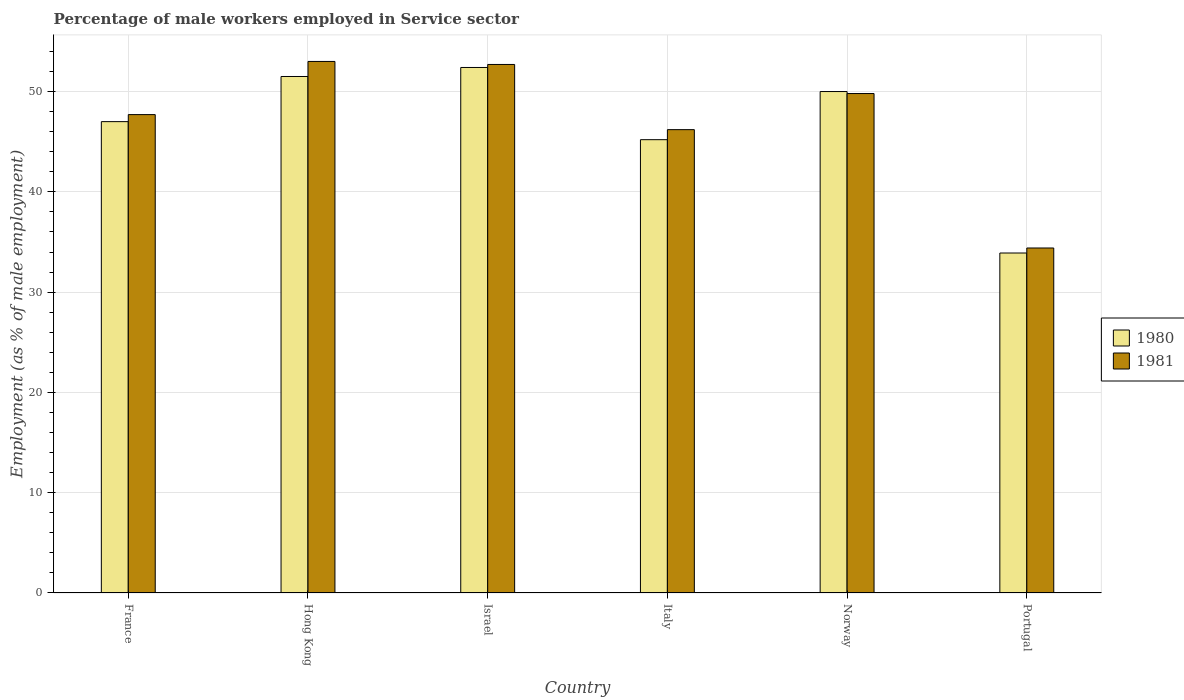Are the number of bars per tick equal to the number of legend labels?
Make the answer very short. Yes. Are the number of bars on each tick of the X-axis equal?
Keep it short and to the point. Yes. What is the percentage of male workers employed in Service sector in 1980 in France?
Keep it short and to the point. 47. Across all countries, what is the maximum percentage of male workers employed in Service sector in 1980?
Make the answer very short. 52.4. Across all countries, what is the minimum percentage of male workers employed in Service sector in 1980?
Offer a very short reply. 33.9. In which country was the percentage of male workers employed in Service sector in 1981 maximum?
Your response must be concise. Hong Kong. What is the total percentage of male workers employed in Service sector in 1981 in the graph?
Your response must be concise. 283.8. What is the difference between the percentage of male workers employed in Service sector in 1981 in France and the percentage of male workers employed in Service sector in 1980 in Portugal?
Your answer should be very brief. 13.8. What is the average percentage of male workers employed in Service sector in 1980 per country?
Keep it short and to the point. 46.67. What is the ratio of the percentage of male workers employed in Service sector in 1981 in Israel to that in Norway?
Your answer should be compact. 1.06. What is the difference between the highest and the second highest percentage of male workers employed in Service sector in 1981?
Offer a very short reply. -2.9. What is the difference between the highest and the lowest percentage of male workers employed in Service sector in 1980?
Offer a very short reply. 18.5. In how many countries, is the percentage of male workers employed in Service sector in 1980 greater than the average percentage of male workers employed in Service sector in 1980 taken over all countries?
Your response must be concise. 4. What does the 1st bar from the left in Norway represents?
Your answer should be compact. 1980. What does the 1st bar from the right in France represents?
Offer a very short reply. 1981. Are all the bars in the graph horizontal?
Give a very brief answer. No. How many countries are there in the graph?
Your answer should be compact. 6. Does the graph contain any zero values?
Provide a short and direct response. No. Does the graph contain grids?
Ensure brevity in your answer.  Yes. How many legend labels are there?
Keep it short and to the point. 2. How are the legend labels stacked?
Ensure brevity in your answer.  Vertical. What is the title of the graph?
Your response must be concise. Percentage of male workers employed in Service sector. Does "2011" appear as one of the legend labels in the graph?
Offer a very short reply. No. What is the label or title of the Y-axis?
Offer a very short reply. Employment (as % of male employment). What is the Employment (as % of male employment) in 1980 in France?
Give a very brief answer. 47. What is the Employment (as % of male employment) of 1981 in France?
Offer a very short reply. 47.7. What is the Employment (as % of male employment) in 1980 in Hong Kong?
Your answer should be compact. 51.5. What is the Employment (as % of male employment) in 1980 in Israel?
Your answer should be very brief. 52.4. What is the Employment (as % of male employment) of 1981 in Israel?
Offer a terse response. 52.7. What is the Employment (as % of male employment) of 1980 in Italy?
Offer a very short reply. 45.2. What is the Employment (as % of male employment) in 1981 in Italy?
Provide a short and direct response. 46.2. What is the Employment (as % of male employment) of 1980 in Norway?
Make the answer very short. 50. What is the Employment (as % of male employment) of 1981 in Norway?
Your answer should be very brief. 49.8. What is the Employment (as % of male employment) of 1980 in Portugal?
Your answer should be very brief. 33.9. What is the Employment (as % of male employment) of 1981 in Portugal?
Your answer should be compact. 34.4. Across all countries, what is the maximum Employment (as % of male employment) in 1980?
Offer a very short reply. 52.4. Across all countries, what is the minimum Employment (as % of male employment) in 1980?
Your answer should be very brief. 33.9. Across all countries, what is the minimum Employment (as % of male employment) of 1981?
Give a very brief answer. 34.4. What is the total Employment (as % of male employment) in 1980 in the graph?
Provide a short and direct response. 280. What is the total Employment (as % of male employment) in 1981 in the graph?
Keep it short and to the point. 283.8. What is the difference between the Employment (as % of male employment) of 1980 in France and that in Hong Kong?
Ensure brevity in your answer.  -4.5. What is the difference between the Employment (as % of male employment) of 1980 in France and that in Italy?
Ensure brevity in your answer.  1.8. What is the difference between the Employment (as % of male employment) in 1980 in France and that in Portugal?
Provide a short and direct response. 13.1. What is the difference between the Employment (as % of male employment) in 1981 in France and that in Portugal?
Your answer should be compact. 13.3. What is the difference between the Employment (as % of male employment) of 1980 in Hong Kong and that in Israel?
Your answer should be compact. -0.9. What is the difference between the Employment (as % of male employment) in 1981 in Hong Kong and that in Israel?
Provide a short and direct response. 0.3. What is the difference between the Employment (as % of male employment) in 1981 in Hong Kong and that in Italy?
Your answer should be very brief. 6.8. What is the difference between the Employment (as % of male employment) of 1980 in Hong Kong and that in Norway?
Your answer should be very brief. 1.5. What is the difference between the Employment (as % of male employment) of 1980 in Hong Kong and that in Portugal?
Provide a succinct answer. 17.6. What is the difference between the Employment (as % of male employment) in 1980 in Israel and that in Italy?
Keep it short and to the point. 7.2. What is the difference between the Employment (as % of male employment) of 1981 in Israel and that in Norway?
Your answer should be compact. 2.9. What is the difference between the Employment (as % of male employment) in 1980 in Israel and that in Portugal?
Offer a very short reply. 18.5. What is the difference between the Employment (as % of male employment) in 1981 in Italy and that in Norway?
Give a very brief answer. -3.6. What is the difference between the Employment (as % of male employment) in 1980 in Italy and that in Portugal?
Your answer should be very brief. 11.3. What is the difference between the Employment (as % of male employment) of 1981 in Italy and that in Portugal?
Ensure brevity in your answer.  11.8. What is the difference between the Employment (as % of male employment) of 1981 in Norway and that in Portugal?
Give a very brief answer. 15.4. What is the difference between the Employment (as % of male employment) in 1980 in France and the Employment (as % of male employment) in 1981 in Hong Kong?
Offer a terse response. -6. What is the difference between the Employment (as % of male employment) of 1980 in France and the Employment (as % of male employment) of 1981 in Israel?
Keep it short and to the point. -5.7. What is the difference between the Employment (as % of male employment) in 1980 in France and the Employment (as % of male employment) in 1981 in Italy?
Ensure brevity in your answer.  0.8. What is the difference between the Employment (as % of male employment) of 1980 in France and the Employment (as % of male employment) of 1981 in Portugal?
Give a very brief answer. 12.6. What is the difference between the Employment (as % of male employment) in 1980 in Hong Kong and the Employment (as % of male employment) in 1981 in Italy?
Ensure brevity in your answer.  5.3. What is the difference between the Employment (as % of male employment) in 1980 in Hong Kong and the Employment (as % of male employment) in 1981 in Portugal?
Provide a short and direct response. 17.1. What is the difference between the Employment (as % of male employment) in 1980 in Israel and the Employment (as % of male employment) in 1981 in Italy?
Offer a very short reply. 6.2. What is the difference between the Employment (as % of male employment) in 1980 in Israel and the Employment (as % of male employment) in 1981 in Norway?
Make the answer very short. 2.6. What is the average Employment (as % of male employment) in 1980 per country?
Make the answer very short. 46.67. What is the average Employment (as % of male employment) in 1981 per country?
Provide a succinct answer. 47.3. What is the difference between the Employment (as % of male employment) in 1980 and Employment (as % of male employment) in 1981 in France?
Your answer should be compact. -0.7. What is the difference between the Employment (as % of male employment) in 1980 and Employment (as % of male employment) in 1981 in Norway?
Your answer should be very brief. 0.2. What is the ratio of the Employment (as % of male employment) of 1980 in France to that in Hong Kong?
Keep it short and to the point. 0.91. What is the ratio of the Employment (as % of male employment) of 1980 in France to that in Israel?
Provide a short and direct response. 0.9. What is the ratio of the Employment (as % of male employment) of 1981 in France to that in Israel?
Your response must be concise. 0.91. What is the ratio of the Employment (as % of male employment) of 1980 in France to that in Italy?
Provide a succinct answer. 1.04. What is the ratio of the Employment (as % of male employment) in 1981 in France to that in Italy?
Your response must be concise. 1.03. What is the ratio of the Employment (as % of male employment) of 1981 in France to that in Norway?
Make the answer very short. 0.96. What is the ratio of the Employment (as % of male employment) of 1980 in France to that in Portugal?
Give a very brief answer. 1.39. What is the ratio of the Employment (as % of male employment) in 1981 in France to that in Portugal?
Offer a terse response. 1.39. What is the ratio of the Employment (as % of male employment) in 1980 in Hong Kong to that in Israel?
Ensure brevity in your answer.  0.98. What is the ratio of the Employment (as % of male employment) of 1980 in Hong Kong to that in Italy?
Offer a terse response. 1.14. What is the ratio of the Employment (as % of male employment) in 1981 in Hong Kong to that in Italy?
Keep it short and to the point. 1.15. What is the ratio of the Employment (as % of male employment) of 1981 in Hong Kong to that in Norway?
Keep it short and to the point. 1.06. What is the ratio of the Employment (as % of male employment) in 1980 in Hong Kong to that in Portugal?
Keep it short and to the point. 1.52. What is the ratio of the Employment (as % of male employment) in 1981 in Hong Kong to that in Portugal?
Ensure brevity in your answer.  1.54. What is the ratio of the Employment (as % of male employment) in 1980 in Israel to that in Italy?
Provide a short and direct response. 1.16. What is the ratio of the Employment (as % of male employment) of 1981 in Israel to that in Italy?
Make the answer very short. 1.14. What is the ratio of the Employment (as % of male employment) in 1980 in Israel to that in Norway?
Make the answer very short. 1.05. What is the ratio of the Employment (as % of male employment) in 1981 in Israel to that in Norway?
Provide a succinct answer. 1.06. What is the ratio of the Employment (as % of male employment) in 1980 in Israel to that in Portugal?
Your answer should be compact. 1.55. What is the ratio of the Employment (as % of male employment) in 1981 in Israel to that in Portugal?
Provide a succinct answer. 1.53. What is the ratio of the Employment (as % of male employment) in 1980 in Italy to that in Norway?
Provide a short and direct response. 0.9. What is the ratio of the Employment (as % of male employment) of 1981 in Italy to that in Norway?
Make the answer very short. 0.93. What is the ratio of the Employment (as % of male employment) of 1980 in Italy to that in Portugal?
Your answer should be compact. 1.33. What is the ratio of the Employment (as % of male employment) of 1981 in Italy to that in Portugal?
Your answer should be compact. 1.34. What is the ratio of the Employment (as % of male employment) of 1980 in Norway to that in Portugal?
Your response must be concise. 1.47. What is the ratio of the Employment (as % of male employment) of 1981 in Norway to that in Portugal?
Provide a succinct answer. 1.45. What is the difference between the highest and the second highest Employment (as % of male employment) in 1980?
Ensure brevity in your answer.  0.9. What is the difference between the highest and the lowest Employment (as % of male employment) of 1980?
Provide a succinct answer. 18.5. What is the difference between the highest and the lowest Employment (as % of male employment) in 1981?
Your answer should be very brief. 18.6. 